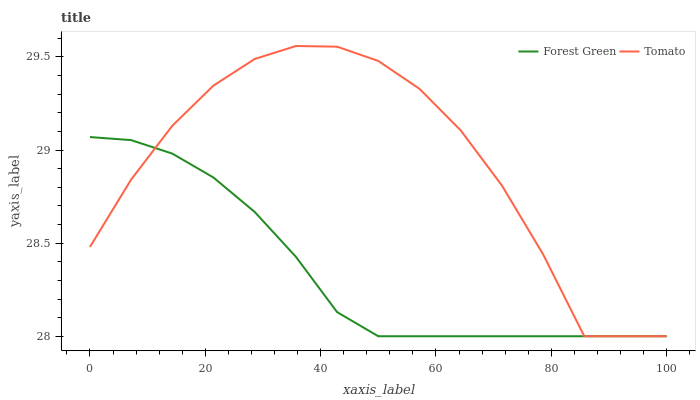Does Forest Green have the minimum area under the curve?
Answer yes or no. Yes. Does Tomato have the maximum area under the curve?
Answer yes or no. Yes. Does Forest Green have the maximum area under the curve?
Answer yes or no. No. Is Forest Green the smoothest?
Answer yes or no. Yes. Is Tomato the roughest?
Answer yes or no. Yes. Is Forest Green the roughest?
Answer yes or no. No. Does Tomato have the highest value?
Answer yes or no. Yes. Does Forest Green have the highest value?
Answer yes or no. No. Does Tomato intersect Forest Green?
Answer yes or no. Yes. Is Tomato less than Forest Green?
Answer yes or no. No. Is Tomato greater than Forest Green?
Answer yes or no. No. 